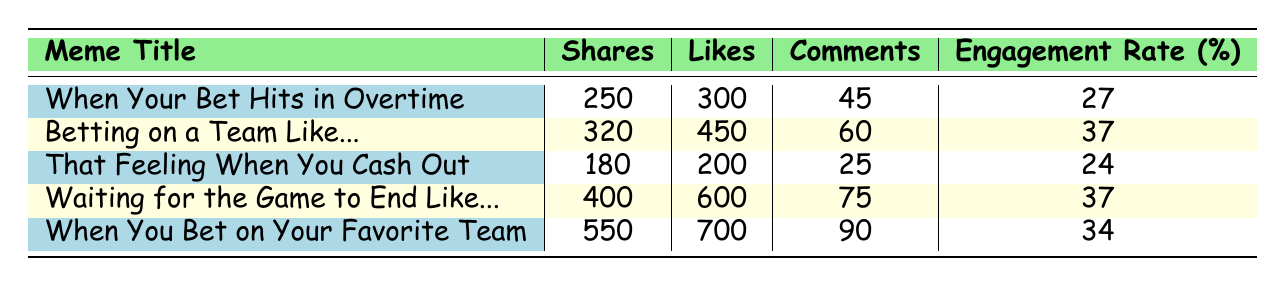What is the meme with the highest engagement rate? The engagement rates for the memes are as follows: "When Your Bet Hits in Overtime" has 27, "Betting on a Team Like..." has 37, "That Feeling When You Cash Out" has 24, "Waiting for the Game to End Like..." has 37, and "When You Bet on Your Favorite Team" has 34. The maximum value is 37, found in two memes: "Betting on a Team Like..." and "Waiting for the Game to End Like...".
Answer: Betting on a Team Like... and Waiting for the Game to End Like.. How many shares did "When You Bet on Your Favorite Team" receive? The number of shares for "When You Bet on Your Favorite Team" is listed in the table as 550, taken directly from the shares column.
Answer: 550 What is the total number of likes across all memes? To find the total number of likes, we sum the likes for each meme: 300 + 450 + 200 + 600 + 700 = 2250.
Answer: 2250 Is the engagement rate of "That Feeling When You Cash Out" greater than 30%? The engagement rate for "That Feeling When You Cash Out" is 24%, which is less than 30%. Therefore, the answer is no.
Answer: No Which meme has the lowest number of comments? The comments for each meme are as follows: 45, 60, 25, 75, and 90. The lowest is 25 comments for "That Feeling When You Cash Out".
Answer: That Feeling When You Cash Out What is the average number of shares for all memes? To compute the average shares, first add all shares: 250 + 320 + 180 + 400 + 550 = 1700. Then, divide by the total number of memes, which is 5. Thus, the average is 1700 / 5 = 340.
Answer: 340 How many memes have an engagement rate of 37%? The engagement rates are 27, 37, 24, 37, and 34. There are two memes with an engagement rate of 37%: "Betting on a Team Like..." and "Waiting for the Game to End Like...".
Answer: 2 What is the difference in likes between the meme with the most likes and the one with the least likes? The most likes are for "When You Bet on Your Favorite Team" with 700 likes, while the least likes are for "That Feeling When You Cash Out" with 200 likes. The difference is 700 - 200 = 500.
Answer: 500 